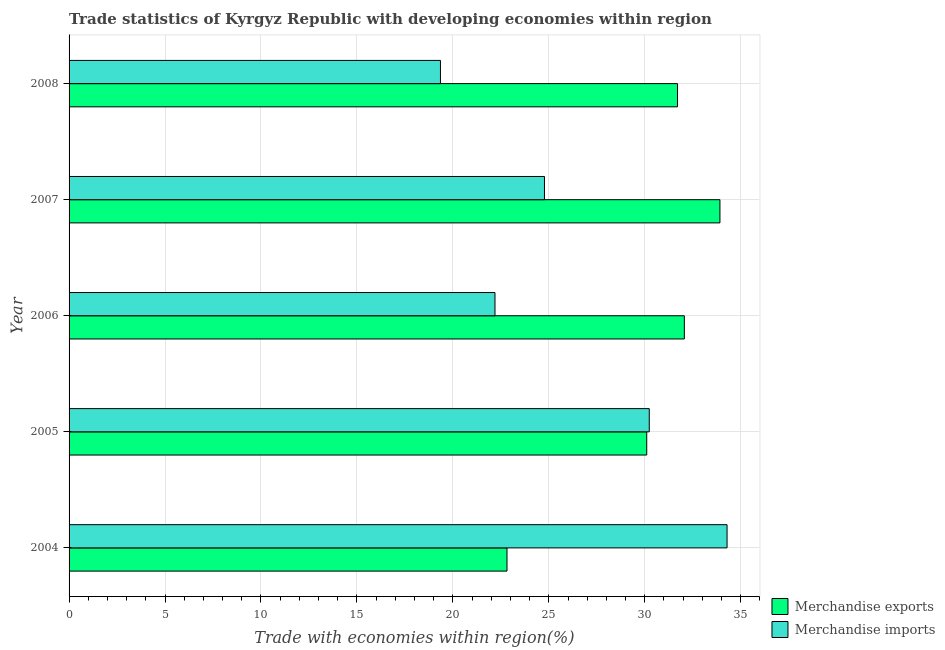How many bars are there on the 2nd tick from the top?
Your answer should be very brief. 2. What is the label of the 4th group of bars from the top?
Your answer should be very brief. 2005. In how many cases, is the number of bars for a given year not equal to the number of legend labels?
Offer a terse response. 0. What is the merchandise exports in 2007?
Provide a succinct answer. 33.92. Across all years, what is the maximum merchandise imports?
Give a very brief answer. 34.29. Across all years, what is the minimum merchandise imports?
Ensure brevity in your answer.  19.35. What is the total merchandise imports in the graph?
Provide a short and direct response. 130.84. What is the difference between the merchandise imports in 2004 and that in 2005?
Give a very brief answer. 4.05. What is the difference between the merchandise imports in 2004 and the merchandise exports in 2007?
Provide a short and direct response. 0.37. What is the average merchandise exports per year?
Provide a short and direct response. 30.12. In the year 2008, what is the difference between the merchandise imports and merchandise exports?
Your answer should be very brief. -12.35. What is the ratio of the merchandise exports in 2004 to that in 2005?
Give a very brief answer. 0.76. Is the difference between the merchandise exports in 2006 and 2008 greater than the difference between the merchandise imports in 2006 and 2008?
Ensure brevity in your answer.  No. What is the difference between the highest and the second highest merchandise imports?
Your response must be concise. 4.05. What is the difference between the highest and the lowest merchandise imports?
Offer a very short reply. 14.94. Is the sum of the merchandise imports in 2005 and 2007 greater than the maximum merchandise exports across all years?
Your response must be concise. Yes. What does the 2nd bar from the top in 2008 represents?
Provide a short and direct response. Merchandise exports. How many bars are there?
Offer a very short reply. 10. How many years are there in the graph?
Your response must be concise. 5. What is the difference between two consecutive major ticks on the X-axis?
Your response must be concise. 5. How are the legend labels stacked?
Give a very brief answer. Vertical. What is the title of the graph?
Your response must be concise. Trade statistics of Kyrgyz Republic with developing economies within region. Does "Formally registered" appear as one of the legend labels in the graph?
Provide a succinct answer. No. What is the label or title of the X-axis?
Ensure brevity in your answer.  Trade with economies within region(%). What is the Trade with economies within region(%) in Merchandise exports in 2004?
Give a very brief answer. 22.82. What is the Trade with economies within region(%) of Merchandise imports in 2004?
Your response must be concise. 34.29. What is the Trade with economies within region(%) in Merchandise exports in 2005?
Ensure brevity in your answer.  30.1. What is the Trade with economies within region(%) in Merchandise imports in 2005?
Offer a terse response. 30.23. What is the Trade with economies within region(%) in Merchandise exports in 2006?
Make the answer very short. 32.06. What is the Trade with economies within region(%) of Merchandise imports in 2006?
Provide a short and direct response. 22.19. What is the Trade with economies within region(%) of Merchandise exports in 2007?
Your answer should be very brief. 33.92. What is the Trade with economies within region(%) in Merchandise imports in 2007?
Provide a short and direct response. 24.77. What is the Trade with economies within region(%) of Merchandise exports in 2008?
Provide a succinct answer. 31.71. What is the Trade with economies within region(%) of Merchandise imports in 2008?
Keep it short and to the point. 19.35. Across all years, what is the maximum Trade with economies within region(%) in Merchandise exports?
Your answer should be compact. 33.92. Across all years, what is the maximum Trade with economies within region(%) in Merchandise imports?
Offer a very short reply. 34.29. Across all years, what is the minimum Trade with economies within region(%) of Merchandise exports?
Make the answer very short. 22.82. Across all years, what is the minimum Trade with economies within region(%) of Merchandise imports?
Your response must be concise. 19.35. What is the total Trade with economies within region(%) in Merchandise exports in the graph?
Offer a very short reply. 150.61. What is the total Trade with economies within region(%) of Merchandise imports in the graph?
Ensure brevity in your answer.  130.84. What is the difference between the Trade with economies within region(%) in Merchandise exports in 2004 and that in 2005?
Ensure brevity in your answer.  -7.28. What is the difference between the Trade with economies within region(%) of Merchandise imports in 2004 and that in 2005?
Keep it short and to the point. 4.05. What is the difference between the Trade with economies within region(%) of Merchandise exports in 2004 and that in 2006?
Your answer should be very brief. -9.24. What is the difference between the Trade with economies within region(%) of Merchandise imports in 2004 and that in 2006?
Your response must be concise. 12.09. What is the difference between the Trade with economies within region(%) in Merchandise exports in 2004 and that in 2007?
Your answer should be compact. -11.1. What is the difference between the Trade with economies within region(%) of Merchandise imports in 2004 and that in 2007?
Offer a very short reply. 9.52. What is the difference between the Trade with economies within region(%) in Merchandise exports in 2004 and that in 2008?
Ensure brevity in your answer.  -8.89. What is the difference between the Trade with economies within region(%) in Merchandise imports in 2004 and that in 2008?
Provide a short and direct response. 14.94. What is the difference between the Trade with economies within region(%) in Merchandise exports in 2005 and that in 2006?
Your response must be concise. -1.96. What is the difference between the Trade with economies within region(%) of Merchandise imports in 2005 and that in 2006?
Provide a short and direct response. 8.04. What is the difference between the Trade with economies within region(%) of Merchandise exports in 2005 and that in 2007?
Your answer should be very brief. -3.81. What is the difference between the Trade with economies within region(%) of Merchandise imports in 2005 and that in 2007?
Ensure brevity in your answer.  5.46. What is the difference between the Trade with economies within region(%) of Merchandise exports in 2005 and that in 2008?
Ensure brevity in your answer.  -1.6. What is the difference between the Trade with economies within region(%) of Merchandise imports in 2005 and that in 2008?
Provide a short and direct response. 10.88. What is the difference between the Trade with economies within region(%) of Merchandise exports in 2006 and that in 2007?
Provide a short and direct response. -1.85. What is the difference between the Trade with economies within region(%) of Merchandise imports in 2006 and that in 2007?
Give a very brief answer. -2.58. What is the difference between the Trade with economies within region(%) in Merchandise exports in 2006 and that in 2008?
Offer a terse response. 0.36. What is the difference between the Trade with economies within region(%) in Merchandise imports in 2006 and that in 2008?
Provide a succinct answer. 2.84. What is the difference between the Trade with economies within region(%) of Merchandise exports in 2007 and that in 2008?
Your response must be concise. 2.21. What is the difference between the Trade with economies within region(%) of Merchandise imports in 2007 and that in 2008?
Offer a terse response. 5.42. What is the difference between the Trade with economies within region(%) of Merchandise exports in 2004 and the Trade with economies within region(%) of Merchandise imports in 2005?
Give a very brief answer. -7.41. What is the difference between the Trade with economies within region(%) of Merchandise exports in 2004 and the Trade with economies within region(%) of Merchandise imports in 2006?
Your answer should be very brief. 0.63. What is the difference between the Trade with economies within region(%) of Merchandise exports in 2004 and the Trade with economies within region(%) of Merchandise imports in 2007?
Offer a terse response. -1.95. What is the difference between the Trade with economies within region(%) of Merchandise exports in 2004 and the Trade with economies within region(%) of Merchandise imports in 2008?
Offer a terse response. 3.47. What is the difference between the Trade with economies within region(%) of Merchandise exports in 2005 and the Trade with economies within region(%) of Merchandise imports in 2006?
Provide a succinct answer. 7.91. What is the difference between the Trade with economies within region(%) in Merchandise exports in 2005 and the Trade with economies within region(%) in Merchandise imports in 2007?
Make the answer very short. 5.33. What is the difference between the Trade with economies within region(%) in Merchandise exports in 2005 and the Trade with economies within region(%) in Merchandise imports in 2008?
Make the answer very short. 10.75. What is the difference between the Trade with economies within region(%) of Merchandise exports in 2006 and the Trade with economies within region(%) of Merchandise imports in 2007?
Your answer should be very brief. 7.29. What is the difference between the Trade with economies within region(%) in Merchandise exports in 2006 and the Trade with economies within region(%) in Merchandise imports in 2008?
Provide a succinct answer. 12.71. What is the difference between the Trade with economies within region(%) of Merchandise exports in 2007 and the Trade with economies within region(%) of Merchandise imports in 2008?
Your response must be concise. 14.56. What is the average Trade with economies within region(%) in Merchandise exports per year?
Ensure brevity in your answer.  30.12. What is the average Trade with economies within region(%) in Merchandise imports per year?
Make the answer very short. 26.17. In the year 2004, what is the difference between the Trade with economies within region(%) of Merchandise exports and Trade with economies within region(%) of Merchandise imports?
Your answer should be compact. -11.47. In the year 2005, what is the difference between the Trade with economies within region(%) in Merchandise exports and Trade with economies within region(%) in Merchandise imports?
Keep it short and to the point. -0.13. In the year 2006, what is the difference between the Trade with economies within region(%) of Merchandise exports and Trade with economies within region(%) of Merchandise imports?
Offer a terse response. 9.87. In the year 2007, what is the difference between the Trade with economies within region(%) of Merchandise exports and Trade with economies within region(%) of Merchandise imports?
Keep it short and to the point. 9.14. In the year 2008, what is the difference between the Trade with economies within region(%) in Merchandise exports and Trade with economies within region(%) in Merchandise imports?
Provide a succinct answer. 12.35. What is the ratio of the Trade with economies within region(%) in Merchandise exports in 2004 to that in 2005?
Give a very brief answer. 0.76. What is the ratio of the Trade with economies within region(%) in Merchandise imports in 2004 to that in 2005?
Offer a very short reply. 1.13. What is the ratio of the Trade with economies within region(%) of Merchandise exports in 2004 to that in 2006?
Your response must be concise. 0.71. What is the ratio of the Trade with economies within region(%) of Merchandise imports in 2004 to that in 2006?
Your answer should be compact. 1.54. What is the ratio of the Trade with economies within region(%) of Merchandise exports in 2004 to that in 2007?
Offer a very short reply. 0.67. What is the ratio of the Trade with economies within region(%) of Merchandise imports in 2004 to that in 2007?
Your response must be concise. 1.38. What is the ratio of the Trade with economies within region(%) of Merchandise exports in 2004 to that in 2008?
Provide a succinct answer. 0.72. What is the ratio of the Trade with economies within region(%) in Merchandise imports in 2004 to that in 2008?
Offer a very short reply. 1.77. What is the ratio of the Trade with economies within region(%) in Merchandise exports in 2005 to that in 2006?
Keep it short and to the point. 0.94. What is the ratio of the Trade with economies within region(%) in Merchandise imports in 2005 to that in 2006?
Your response must be concise. 1.36. What is the ratio of the Trade with economies within region(%) of Merchandise exports in 2005 to that in 2007?
Make the answer very short. 0.89. What is the ratio of the Trade with economies within region(%) of Merchandise imports in 2005 to that in 2007?
Offer a very short reply. 1.22. What is the ratio of the Trade with economies within region(%) of Merchandise exports in 2005 to that in 2008?
Offer a very short reply. 0.95. What is the ratio of the Trade with economies within region(%) in Merchandise imports in 2005 to that in 2008?
Make the answer very short. 1.56. What is the ratio of the Trade with economies within region(%) in Merchandise exports in 2006 to that in 2007?
Your response must be concise. 0.95. What is the ratio of the Trade with economies within region(%) of Merchandise imports in 2006 to that in 2007?
Ensure brevity in your answer.  0.9. What is the ratio of the Trade with economies within region(%) in Merchandise exports in 2006 to that in 2008?
Make the answer very short. 1.01. What is the ratio of the Trade with economies within region(%) in Merchandise imports in 2006 to that in 2008?
Keep it short and to the point. 1.15. What is the ratio of the Trade with economies within region(%) of Merchandise exports in 2007 to that in 2008?
Make the answer very short. 1.07. What is the ratio of the Trade with economies within region(%) of Merchandise imports in 2007 to that in 2008?
Your answer should be compact. 1.28. What is the difference between the highest and the second highest Trade with economies within region(%) in Merchandise exports?
Your answer should be very brief. 1.85. What is the difference between the highest and the second highest Trade with economies within region(%) in Merchandise imports?
Make the answer very short. 4.05. What is the difference between the highest and the lowest Trade with economies within region(%) in Merchandise exports?
Offer a terse response. 11.1. What is the difference between the highest and the lowest Trade with economies within region(%) of Merchandise imports?
Your answer should be compact. 14.94. 